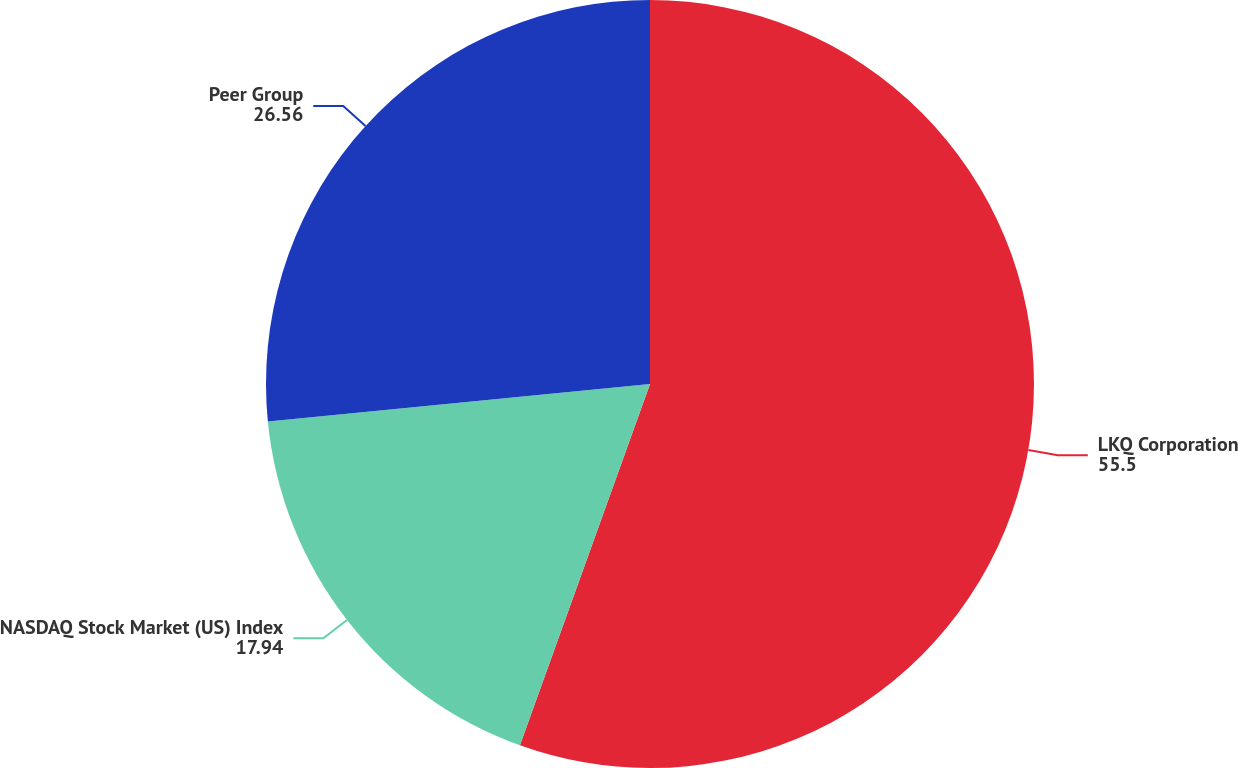<chart> <loc_0><loc_0><loc_500><loc_500><pie_chart><fcel>LKQ Corporation<fcel>NASDAQ Stock Market (US) Index<fcel>Peer Group<nl><fcel>55.5%<fcel>17.94%<fcel>26.56%<nl></chart> 